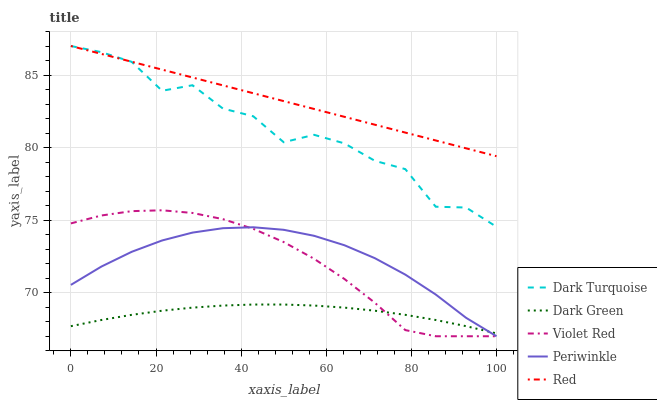Does Dark Green have the minimum area under the curve?
Answer yes or no. Yes. Does Red have the maximum area under the curve?
Answer yes or no. Yes. Does Violet Red have the minimum area under the curve?
Answer yes or no. No. Does Violet Red have the maximum area under the curve?
Answer yes or no. No. Is Red the smoothest?
Answer yes or no. Yes. Is Dark Turquoise the roughest?
Answer yes or no. Yes. Is Violet Red the smoothest?
Answer yes or no. No. Is Violet Red the roughest?
Answer yes or no. No. Does Red have the lowest value?
Answer yes or no. No. Does Red have the highest value?
Answer yes or no. Yes. Does Violet Red have the highest value?
Answer yes or no. No. Is Dark Green less than Red?
Answer yes or no. Yes. Is Dark Turquoise greater than Periwinkle?
Answer yes or no. Yes. Does Periwinkle intersect Dark Green?
Answer yes or no. Yes. Is Periwinkle less than Dark Green?
Answer yes or no. No. Is Periwinkle greater than Dark Green?
Answer yes or no. No. Does Dark Green intersect Red?
Answer yes or no. No. 